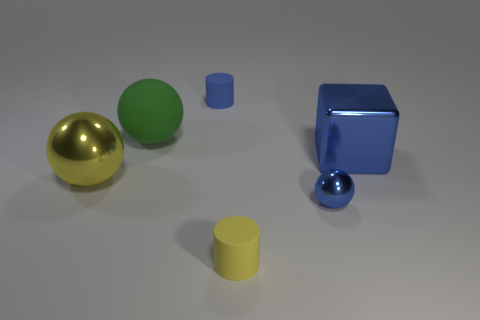What number of other things are there of the same color as the large metal cube?
Give a very brief answer. 2. Does the small blue thing that is to the left of the tiny blue sphere have the same material as the big ball that is behind the block?
Your answer should be compact. Yes. Is the number of green rubber balls behind the blue rubber cylinder the same as the number of rubber objects that are right of the yellow matte thing?
Provide a succinct answer. Yes. There is a yellow object that is behind the blue ball; what material is it?
Give a very brief answer. Metal. Is the number of blue metallic blocks less than the number of blue shiny objects?
Provide a succinct answer. Yes. There is a large object that is both to the left of the tiny blue metallic ball and right of the large metallic sphere; what shape is it?
Offer a terse response. Sphere. How many yellow blocks are there?
Your response must be concise. 0. What is the cylinder behind the small yellow thing right of the rubber cylinder behind the big blue metallic thing made of?
Offer a very short reply. Rubber. How many cylinders are to the left of the big metal thing on the right side of the big metallic sphere?
Give a very brief answer. 2. What is the color of the other small matte object that is the same shape as the blue rubber object?
Your answer should be compact. Yellow. 